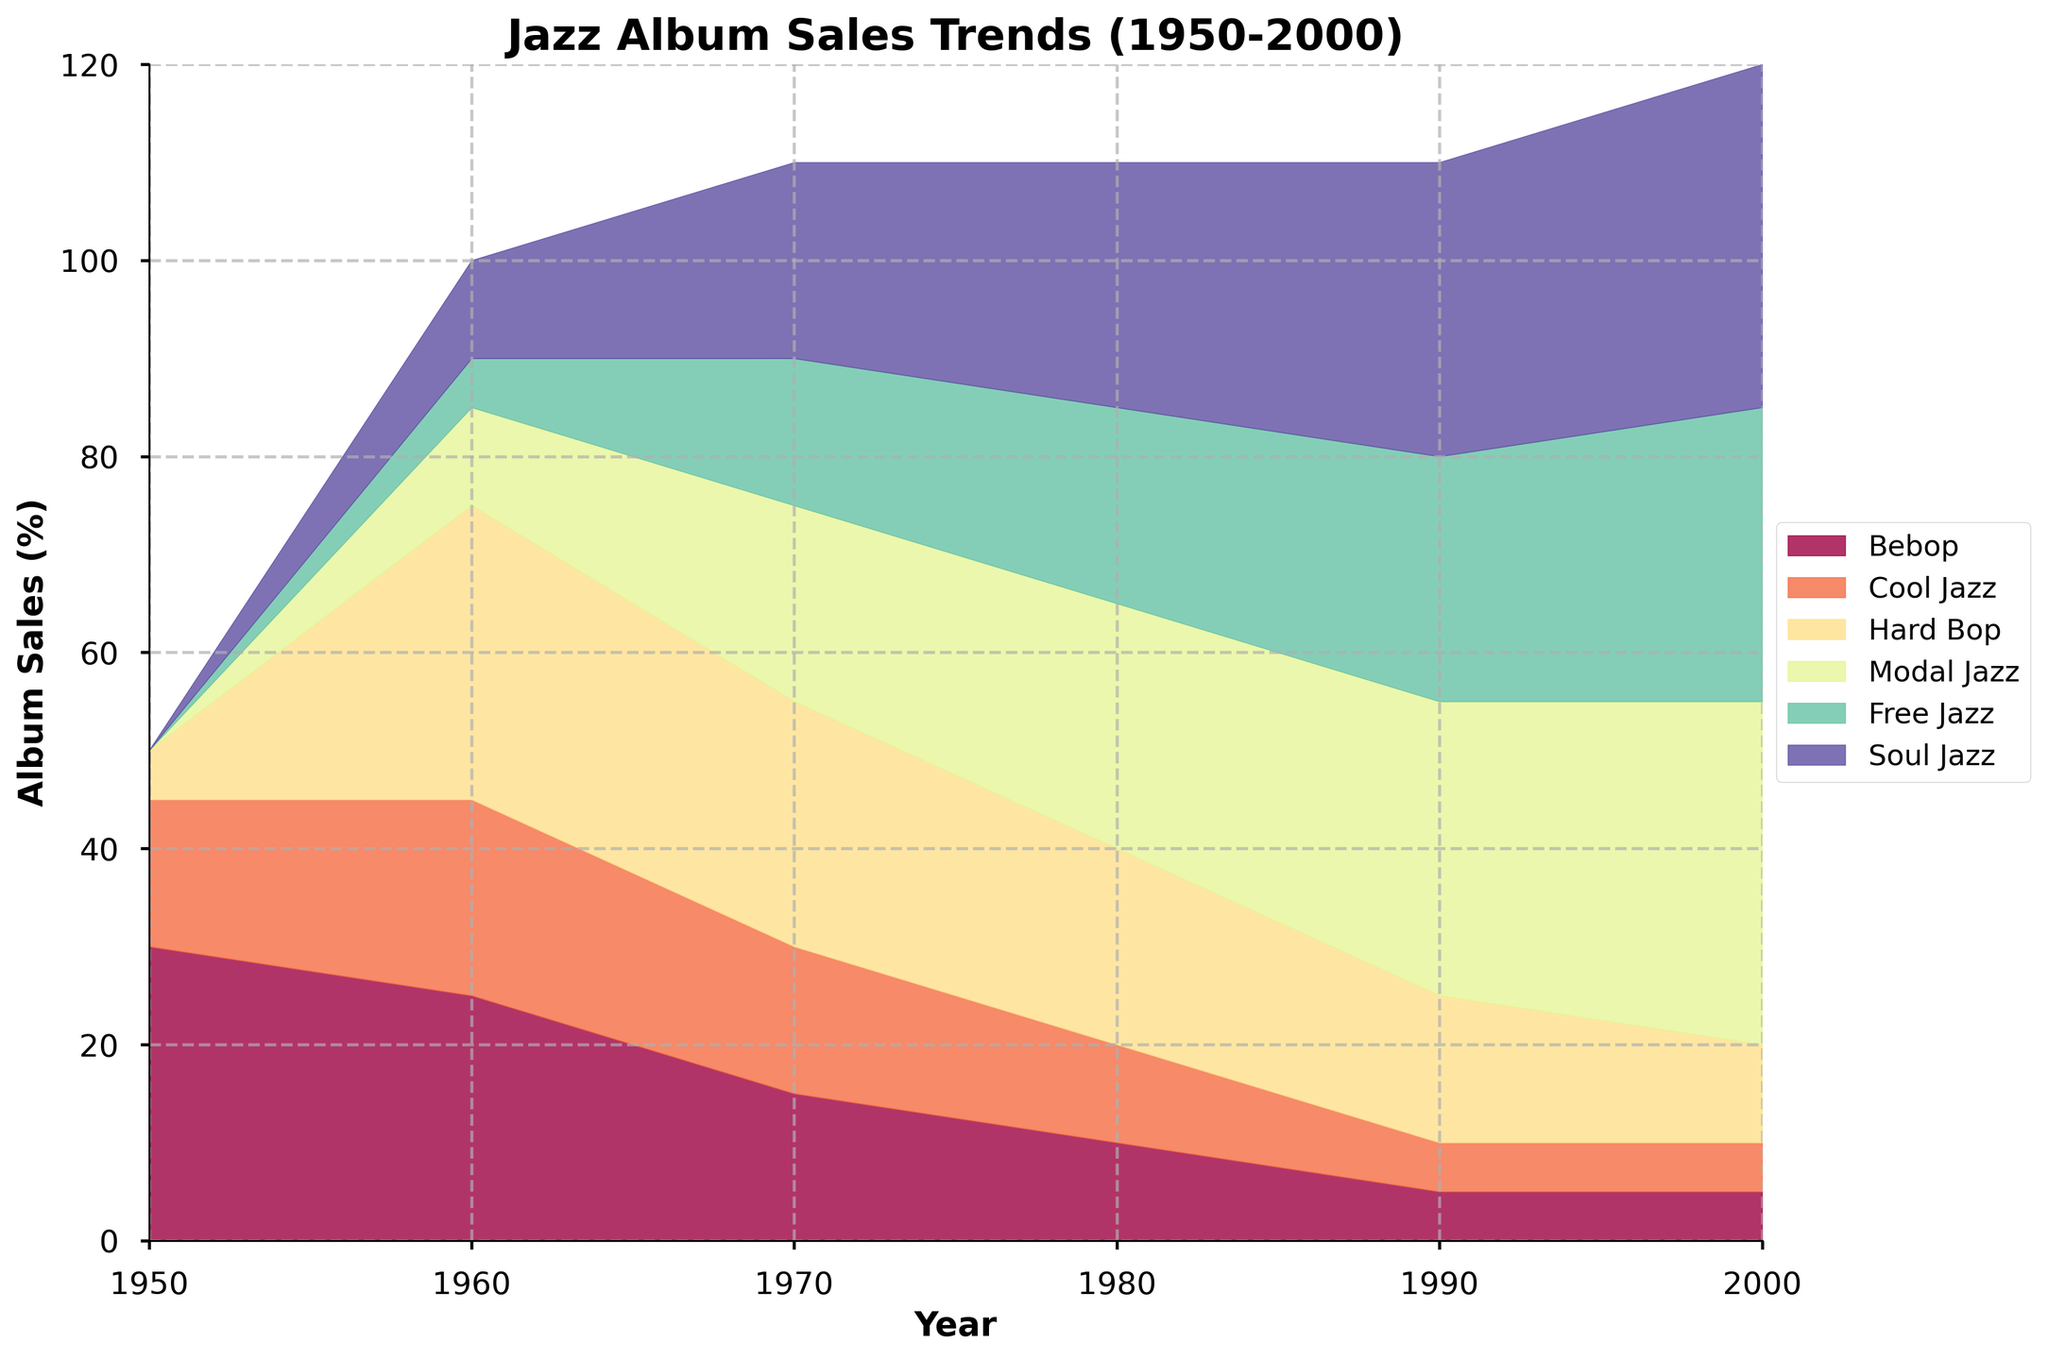What is the title of the chart? The title of the chart is displayed at the top center of the figure.
Answer: Jazz Album Sales Trends (1950-2000) Which genre had the highest album sales in 1960? To find the genre with the highest sales in 1960, look at the legend and compare the filled areas directly above the value of '1960' on the x-axis. Bebop has 25, Cool Jazz 20, Hard Bop 30, Modal Jazz 10, Free Jazz 5, Soul Jazz 10. Hard Bop has the highest value.
Answer: Hard Bop How many different subgenres are represented in the chart? Count the number of different colored segments in the chart's legend. There are six: Bebop, Cool Jazz, Hard Bop, Modal Jazz, Free Jazz, Soul Jazz.
Answer: 6 By how much did the album sales percentage of Bebop decrease from 1950 to 2000? Subtract the 2000 Bebop value from the 1950 value. In 1950, Bebop sales are at 30%, and in 2000, it is 5%. The decrease is 30 - 5 = 25%.
Answer: 25% What was the total percentage of album sales for Modal Jazz and Soul Jazz in 1980? To answer this, add the percentage values of Modal Jazz and Soul Jazz in 1980. Modal Jazz has 25% and Soul Jazz has 25%, so the total is 25 + 25 = 50%.
Answer: 50% Which subgenre became the most popular by 2000? Examine the highest segment in 2000 by checking the topmost filled area at the year 2000. The genre with the highest value in 2000 is Soul Jazz, at 35%.
Answer: Soul Jazz In which decade did Free Jazz first appear on the chart? Free Jazz first appears in the chart in 1960, at a value of 5%.
Answer: 1960 What general trend can you observe for Bebop album sales from 1950 to 2000? The percentage of album sales for Bebop decreases consistently from 1950 (30%) to 2000 (5%). This indicates a general decline in popularity.
Answer: General decline How does the complexity of the chart help in interpreting the trends across multiple genres over time? The use of different colors and layers allows for easy differentiation of each genre's sales trends over the decades, making it clear how each genre's popularity changes relative to others.
Answer: Differentiates trends effectively 